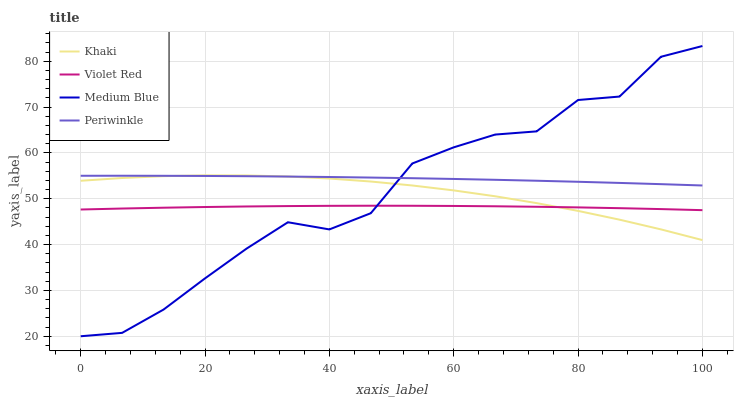Does Khaki have the minimum area under the curve?
Answer yes or no. No. Does Khaki have the maximum area under the curve?
Answer yes or no. No. Is Violet Red the smoothest?
Answer yes or no. No. Is Violet Red the roughest?
Answer yes or no. No. Does Violet Red have the lowest value?
Answer yes or no. No. Does Khaki have the highest value?
Answer yes or no. No. Is Violet Red less than Periwinkle?
Answer yes or no. Yes. Is Periwinkle greater than Violet Red?
Answer yes or no. Yes. Does Violet Red intersect Periwinkle?
Answer yes or no. No. 